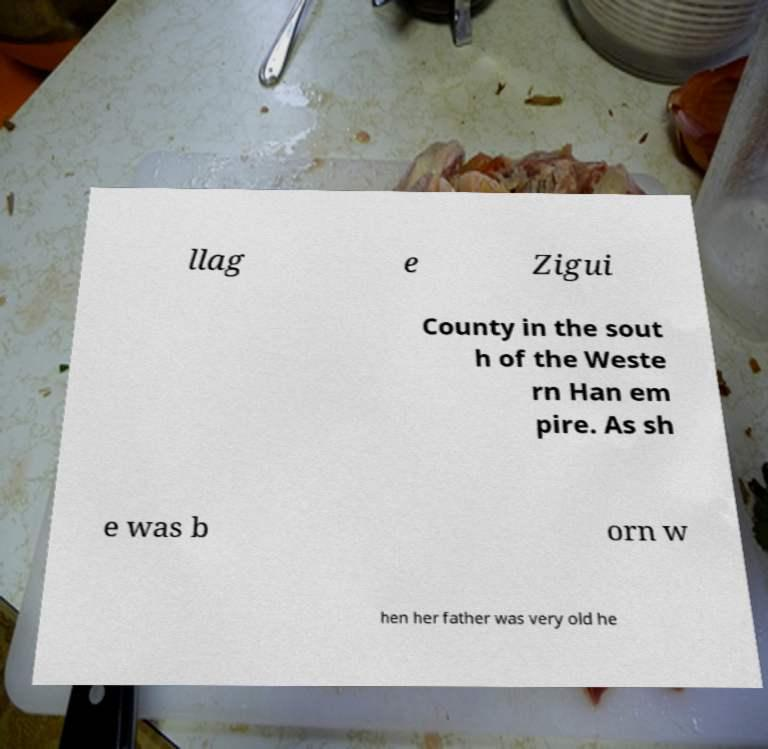Can you read and provide the text displayed in the image?This photo seems to have some interesting text. Can you extract and type it out for me? llag e Zigui County in the sout h of the Weste rn Han em pire. As sh e was b orn w hen her father was very old he 